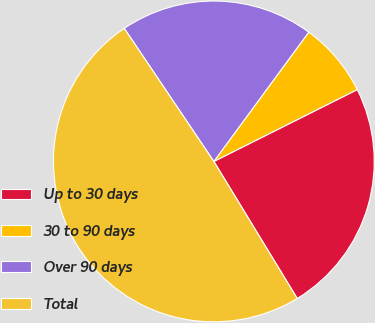<chart> <loc_0><loc_0><loc_500><loc_500><pie_chart><fcel>Up to 30 days<fcel>30 to 90 days<fcel>Over 90 days<fcel>Total<nl><fcel>23.69%<fcel>7.53%<fcel>19.51%<fcel>49.27%<nl></chart> 